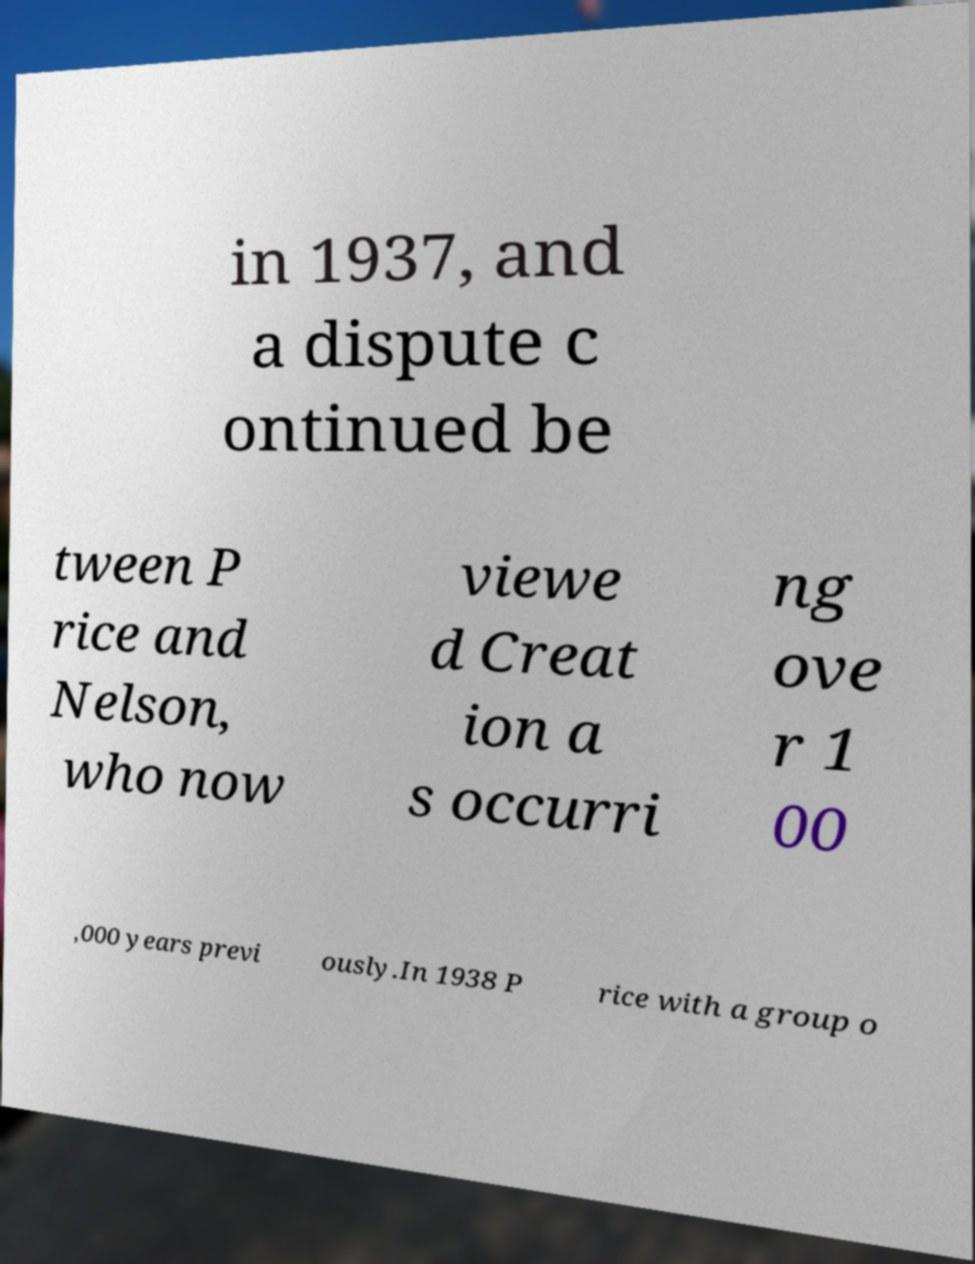What messages or text are displayed in this image? I need them in a readable, typed format. in 1937, and a dispute c ontinued be tween P rice and Nelson, who now viewe d Creat ion a s occurri ng ove r 1 00 ,000 years previ ously.In 1938 P rice with a group o 